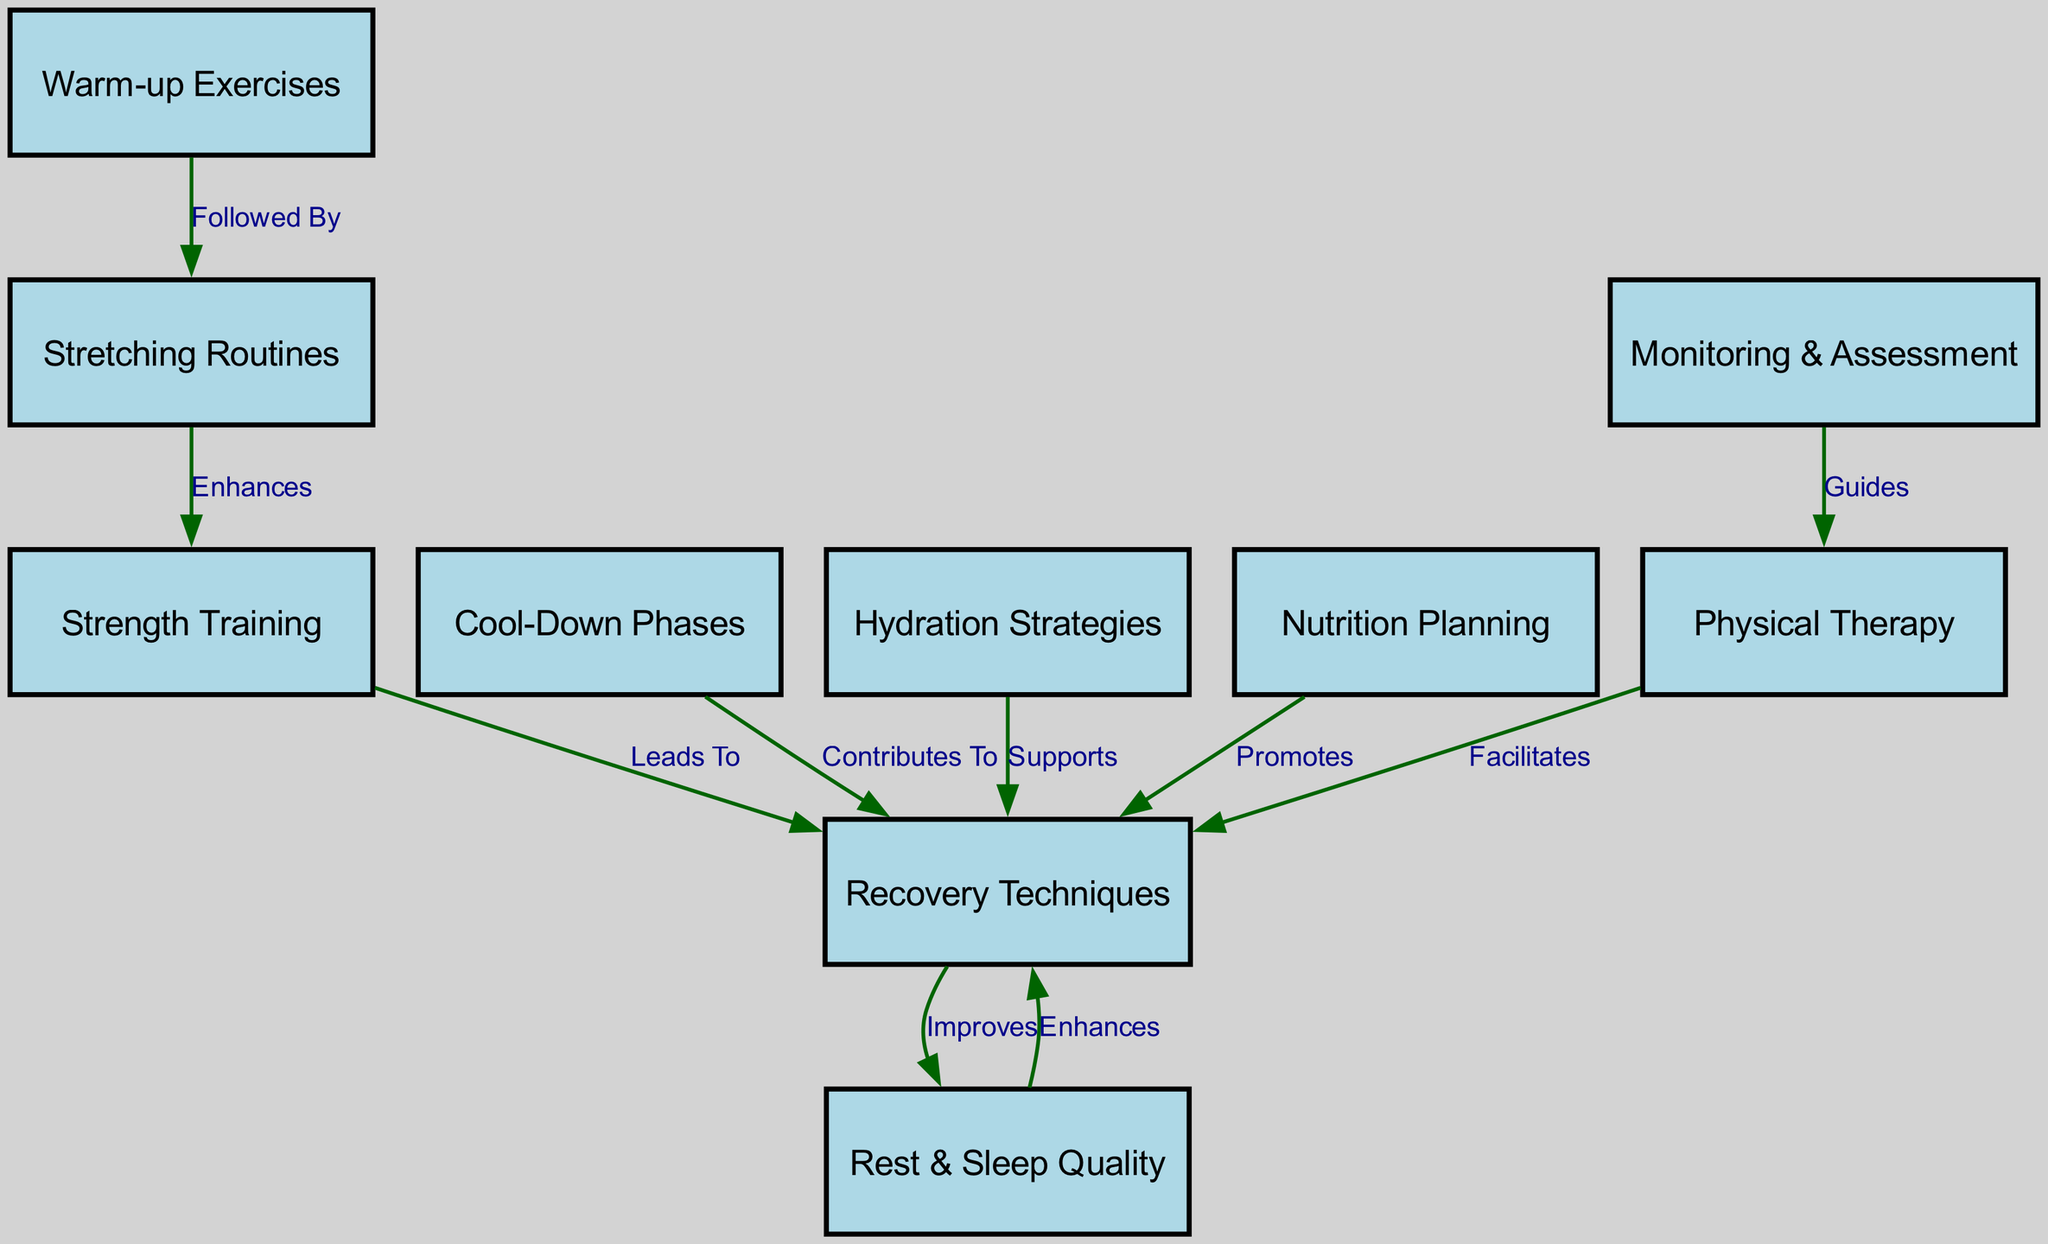What is the first step in the injury prevention protocol? The diagram shows that "Warm-up Exercises" is the initial node that precedes all other activities in the injury prevention protocol.
Answer: Warm-up Exercises What type of routine follows warm-up exercises? According to the diagram, "Stretching Routines" is directly connected to "Warm-up Exercises" with the label "Followed By," indicating that it comes next in the sequence.
Answer: Stretching Routines Which activity enhances stretching routines? The diagram specifies that "Strength Training" enhances "Stretching Routines," as denoted by the edge labeled "Enhances."
Answer: Strength Training How many total nodes are represented in the diagram? By counting the distinct nodes listed in the provided data, there are 10 nodes in total related to the injury prevention and recovery protocols.
Answer: 10 What leads from strength training? The diagram shows that "Strength Training" leads to "Recovery Techniques," which is illustrated by the edge labeled "Leads To."
Answer: Recovery Techniques What supports recovery techniques? The diagram indicates that "Hydration Strategies" supports "Recovery Techniques," as represented by the edge labeled "Supports."
Answer: Hydration Strategies What improves recovery techniques according to the diagram? The edge labeled "Improves" shows that "Rest & Sleep Quality" contributes to the improvement of "Recovery Techniques."
Answer: Rest & Sleep Quality Which node is guided by monitoring and assessment? The diagram indicates that "Monitoring & Assessment" guides "Physical Therapy," as denoted by the edge labeled "Guides."
Answer: Physical Therapy What facilitates recovery techniques? The diagram illustrates that "Physical Therapy" facilitates "Recovery Techniques," indicated by the edge labeled "Facilitates."
Answer: Physical Therapy What contributes to recovery techniques apart from warm-up exercises? Both "Cool-Down Phases" and "Hydration Strategies" are other nodes in the diagram that additionally contribute to "Recovery Techniques," with the edges labeled "Contributes To" and "Supports," respectively.
Answer: Cool-Down Phases, Hydration Strategies 